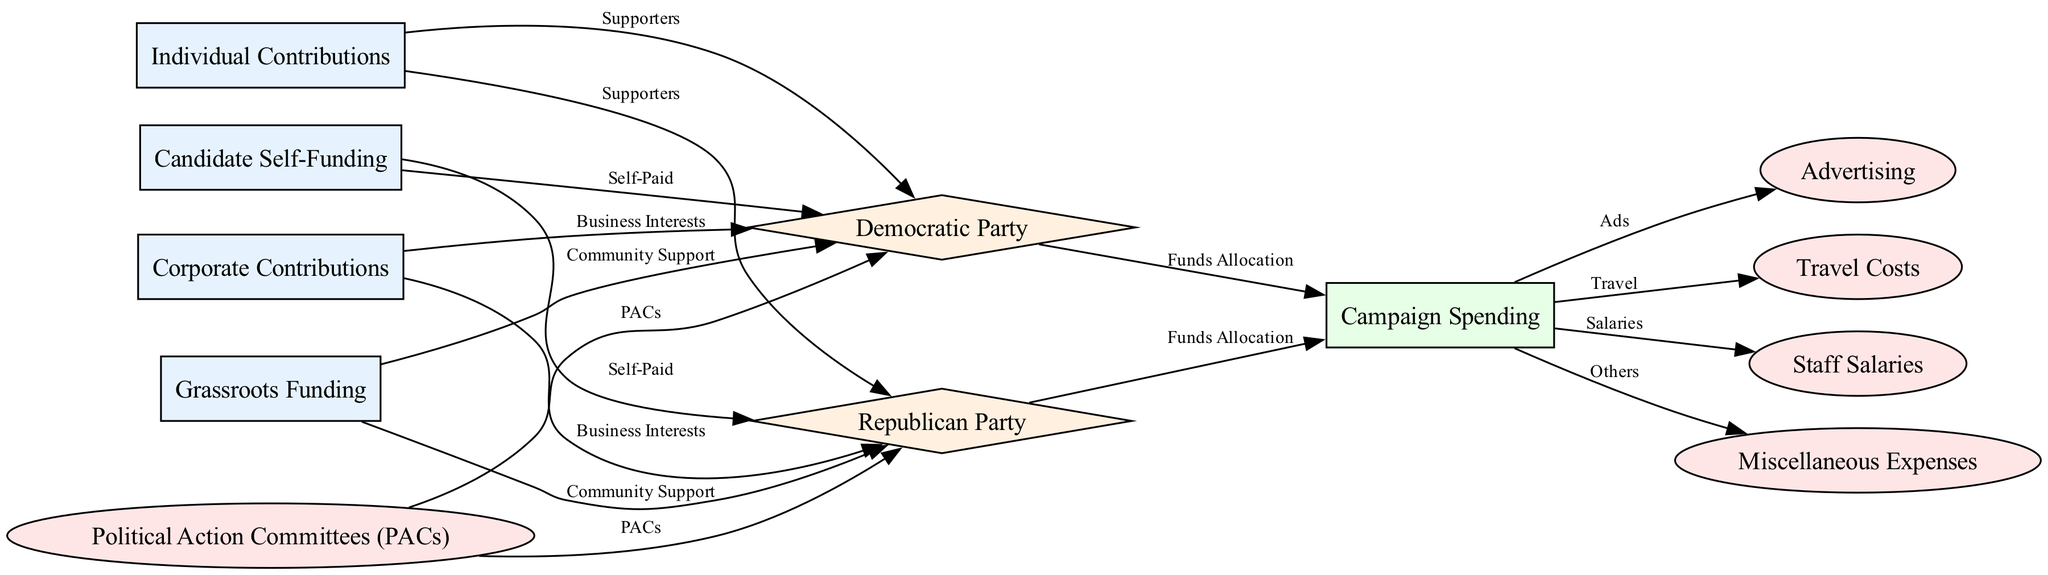What are the two types of contributions represented in the diagram? The diagram clearly lists two types of contributions: "Individual Contributions" and "Corporate Contributions". Each of these types is represented as a node in the diagram.
Answer: Individual Contributions, Corporate Contributions How many parties are represented in the diagram? The diagram features two parties: the "Democratic Party" and the "Republican Party". Each party is represented as a distinct node, totaling two parties in the diagram.
Answer: 2 What is the relationship between individual contributions and the Democratic Party? The edge connecting "Individual Contributions" to "Democratic Party" is labeled "Supporters", indicating that supporters of these contributions are linked to the Democratic Party.
Answer: Supporters Which type of funding is directly connected to "Community Support"? The "Grassroots Funding" node has edges that connect it to both the Democratic Party and the Republican Party, showing that both parties receive funding from community support.
Answer: Grassroots Funding What are the four categories of campaign spending listed in the diagram? The categories of campaign spending represented in the diagram are "Advertising", "Travel Costs", "Staff Salaries", and "Miscellaneous Expenses", all branching out from the "Campaign Spending" node.
Answer: Advertising, Travel Costs, Staff Salaries, Miscellaneous Expenses What type of contributions do Political Action Committees provide? Political Action Committees contribute to both major parties, as indicated by the edge labeled "PACs" that links the "Political Action Committees" node to both the Democratic Party and the Republican Party.
Answer: PACs Which type of spending is specifically labeled as "Self-Paid" in the diagram? The diagram contains the node "Candidate Self-Funding" that is connected to both parties with the label "Self-Paid", indicating that this type of spending is funding from the candidates themselves.
Answer: Candidate Self-Funding Which node is linked to both parties indicating business interests? The "Corporate Contributions" node has edges connecting it to both parties, each labeled as "Business Interests", which signifies that corporate contributions are supporting both the Democratic and Republican parties.
Answer: Corporate Contributions How do both parties allocate funds? The edges from the "Democratic Party" and "Republican Party" lead to the "Campaign Spending" node with the label "Funds Allocation", indicating that both parties allocate their funds in campaign spending uniformly.
Answer: Funds Allocation 